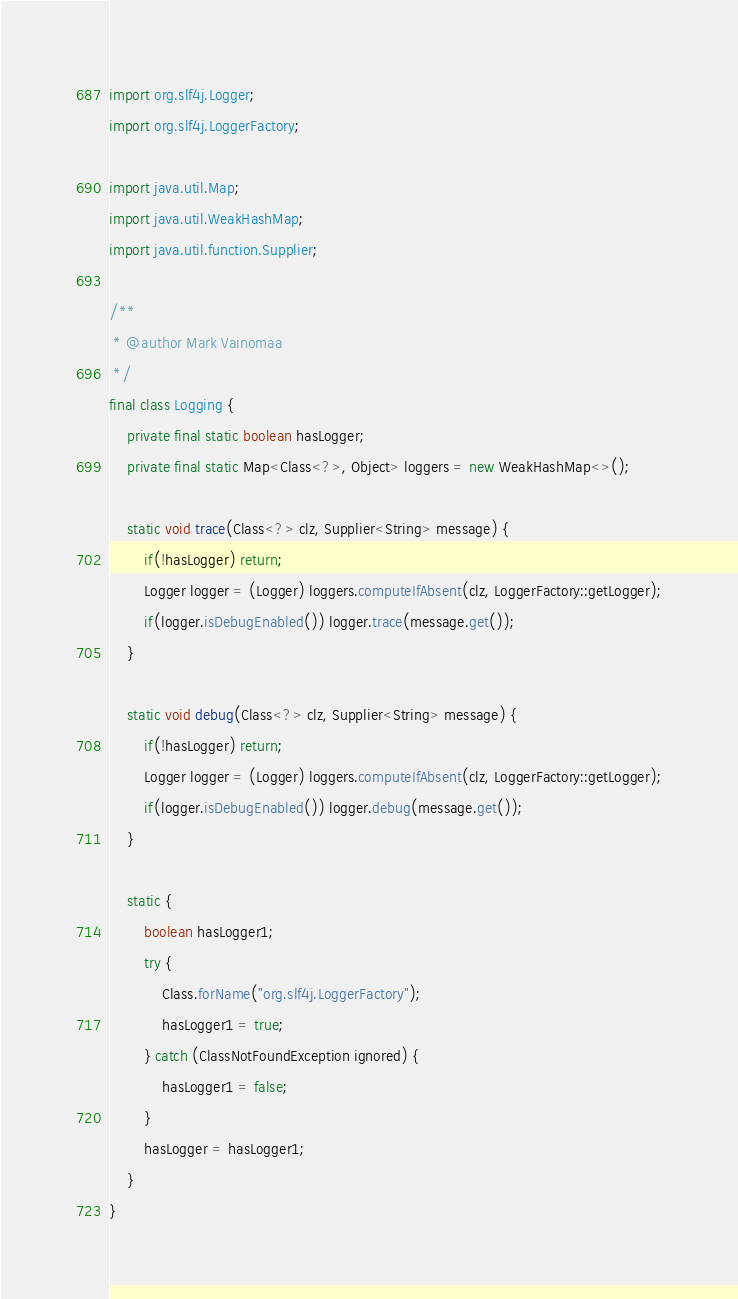Convert code to text. <code><loc_0><loc_0><loc_500><loc_500><_Java_>import org.slf4j.Logger;
import org.slf4j.LoggerFactory;

import java.util.Map;
import java.util.WeakHashMap;
import java.util.function.Supplier;

/**
 * @author Mark Vainomaa
 */
final class Logging {
    private final static boolean hasLogger;
    private final static Map<Class<?>, Object> loggers = new WeakHashMap<>();

    static void trace(Class<?> clz, Supplier<String> message) {
        if(!hasLogger) return;
        Logger logger = (Logger) loggers.computeIfAbsent(clz, LoggerFactory::getLogger);
        if(logger.isDebugEnabled()) logger.trace(message.get());
    }

    static void debug(Class<?> clz, Supplier<String> message) {
        if(!hasLogger) return;
        Logger logger = (Logger) loggers.computeIfAbsent(clz, LoggerFactory::getLogger);
        if(logger.isDebugEnabled()) logger.debug(message.get());
    }

    static {
        boolean hasLogger1;
        try {
            Class.forName("org.slf4j.LoggerFactory");
            hasLogger1 = true;
        } catch (ClassNotFoundException ignored) {
            hasLogger1 = false;
        }
        hasLogger = hasLogger1;
    }
}
</code> 